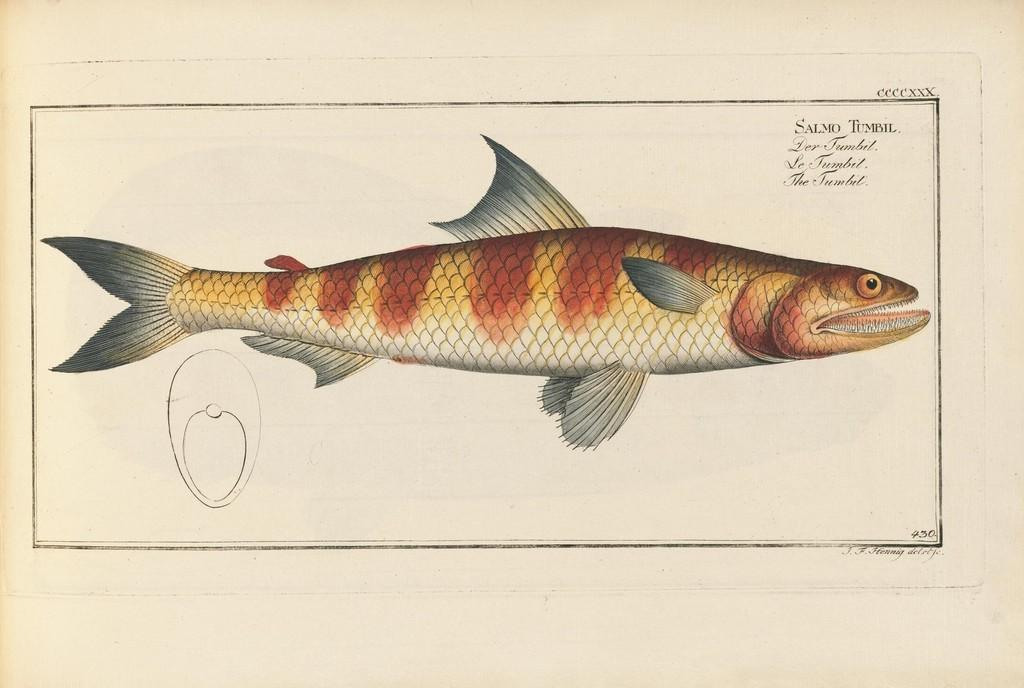What is present on the poster in the image? There is a poster in the image, which has an image and text written on it. Can you describe the image on the poster? Unfortunately, the specific image on the poster cannot be described with the given facts. What type of information is conveyed through the text on the poster? The content of the text on the poster cannot be determined with the provided facts. What type of wool is being used to create the waves in the image? There are no waves or wool present in the image; it only features a poster with an image and text. 